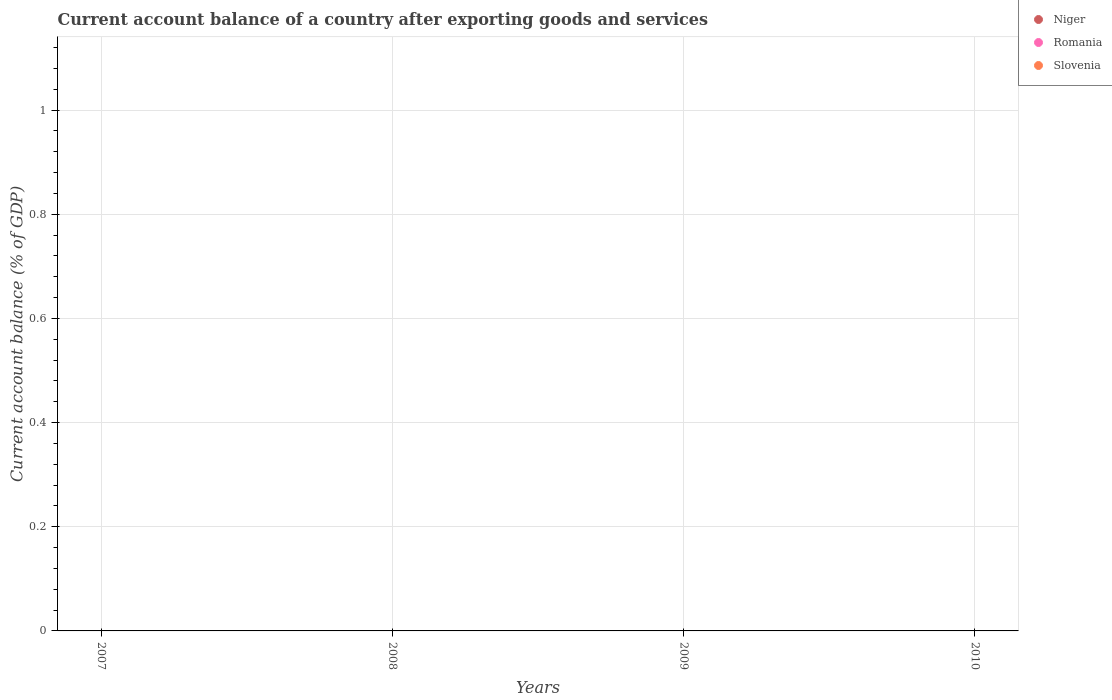How many different coloured dotlines are there?
Ensure brevity in your answer.  0. Is the number of dotlines equal to the number of legend labels?
Provide a succinct answer. No. Across all years, what is the minimum account balance in Niger?
Offer a very short reply. 0. What is the average account balance in Slovenia per year?
Your answer should be compact. 0. Is it the case that in every year, the sum of the account balance in Niger and account balance in Slovenia  is greater than the account balance in Romania?
Your response must be concise. No. Is the account balance in Niger strictly greater than the account balance in Romania over the years?
Keep it short and to the point. No. What is the difference between two consecutive major ticks on the Y-axis?
Provide a succinct answer. 0.2. Does the graph contain grids?
Give a very brief answer. Yes. What is the title of the graph?
Provide a succinct answer. Current account balance of a country after exporting goods and services. Does "Belarus" appear as one of the legend labels in the graph?
Provide a succinct answer. No. What is the label or title of the X-axis?
Offer a terse response. Years. What is the label or title of the Y-axis?
Your answer should be compact. Current account balance (% of GDP). What is the Current account balance (% of GDP) of Romania in 2007?
Your answer should be very brief. 0. What is the Current account balance (% of GDP) in Niger in 2008?
Your answer should be very brief. 0. What is the Current account balance (% of GDP) in Romania in 2008?
Make the answer very short. 0. What is the Current account balance (% of GDP) of Slovenia in 2008?
Ensure brevity in your answer.  0. What is the Current account balance (% of GDP) in Niger in 2009?
Make the answer very short. 0. What is the Current account balance (% of GDP) of Romania in 2009?
Keep it short and to the point. 0. What is the Current account balance (% of GDP) of Slovenia in 2009?
Provide a short and direct response. 0. What is the Current account balance (% of GDP) in Niger in 2010?
Provide a succinct answer. 0. What is the Current account balance (% of GDP) in Romania in 2010?
Offer a terse response. 0. What is the total Current account balance (% of GDP) of Romania in the graph?
Offer a very short reply. 0. What is the average Current account balance (% of GDP) of Niger per year?
Keep it short and to the point. 0. What is the average Current account balance (% of GDP) of Slovenia per year?
Offer a terse response. 0. 